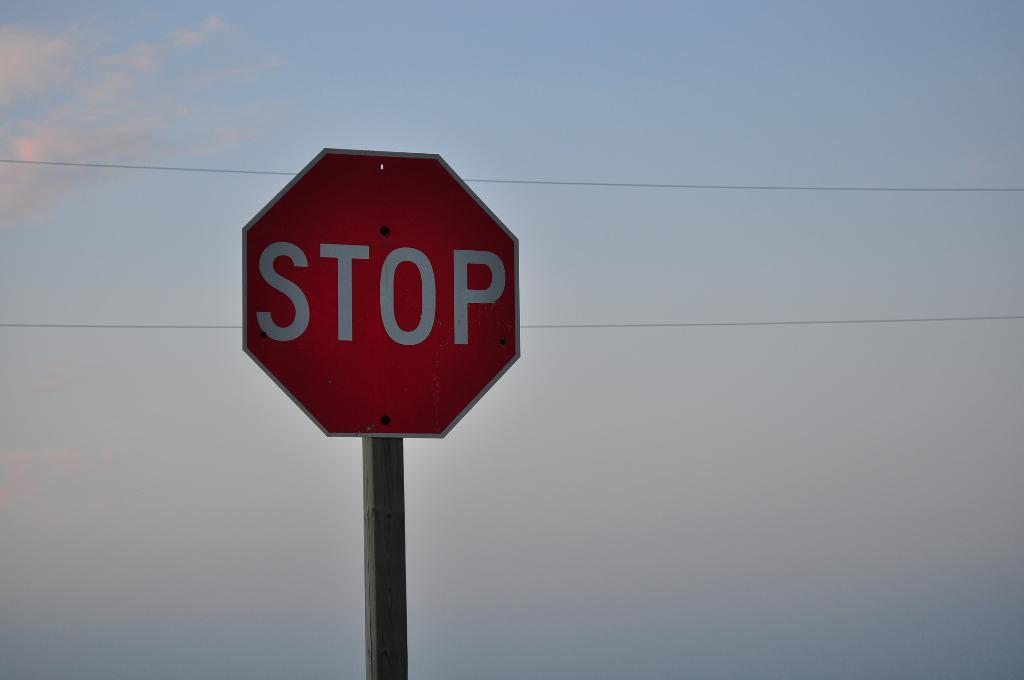<image>
Share a concise interpretation of the image provided. The stop sign sits tall and proud against a clear sky. 